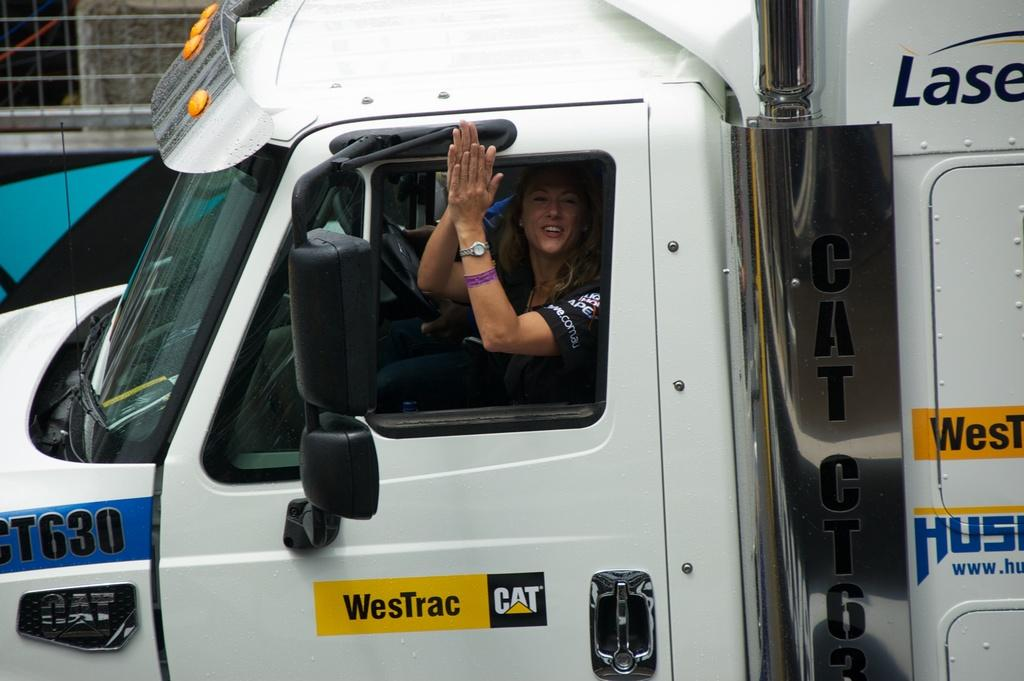Who is present in the image? There is a woman in the image. What is the woman doing in the image? The woman is sitting in a truck. What color is the truck in the image? The truck is white in color. What type of goldfish can be seen swimming in the truck with the woman? There are no goldfish present in the image; it features a woman sitting in a white truck. 